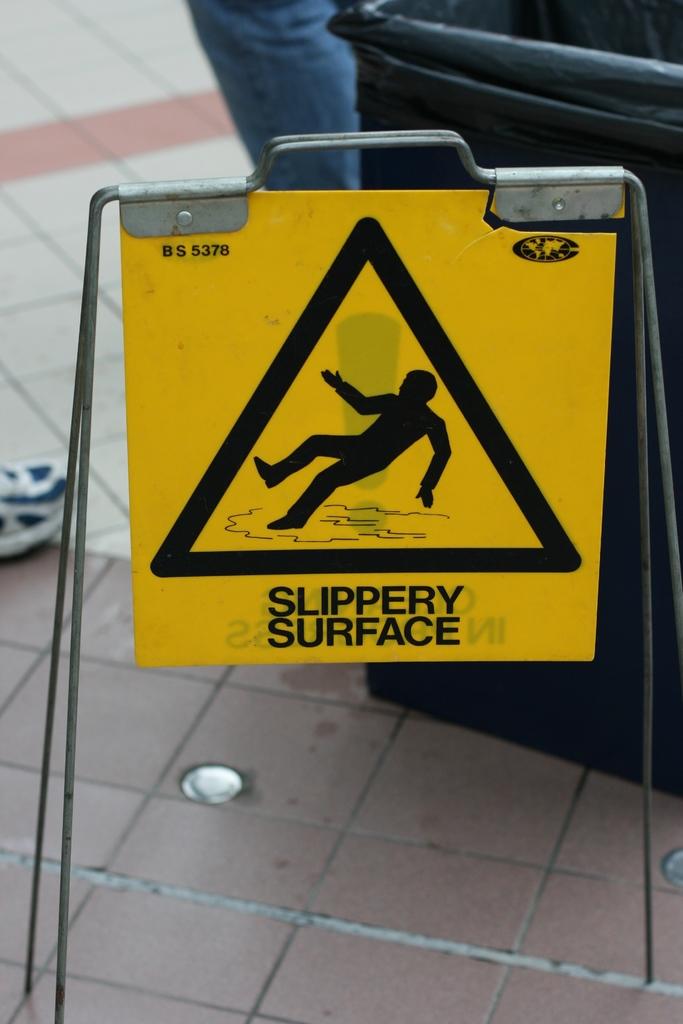What does the sign say is slippery?
Your response must be concise. Surface. Is it slippery?
Offer a very short reply. Yes. 